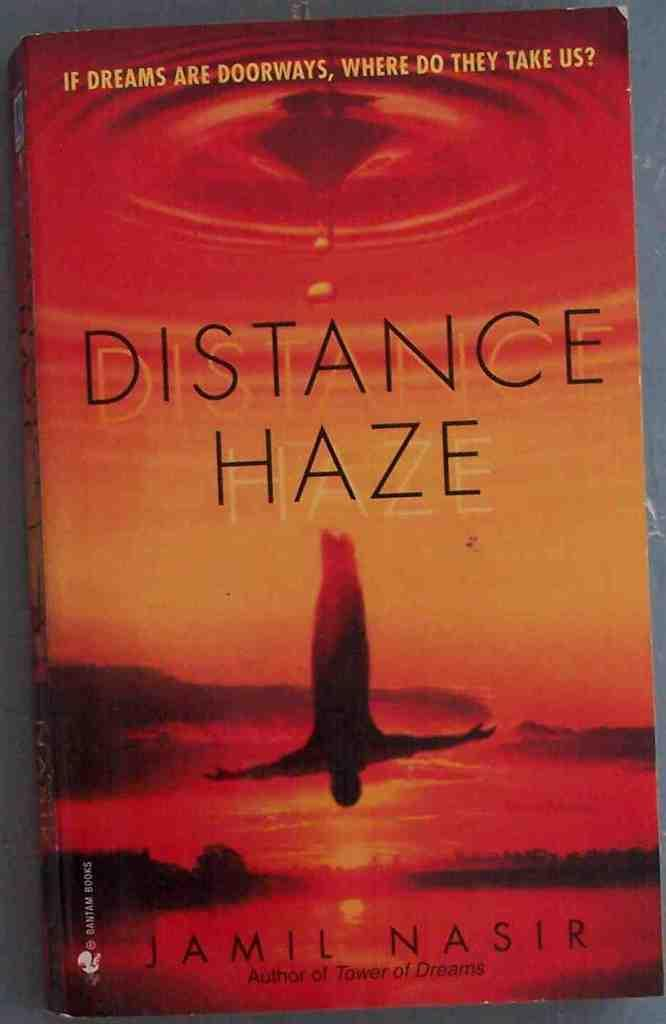<image>
Provide a brief description of the given image. A book called Distance Haze shows a man freediving on the cover 